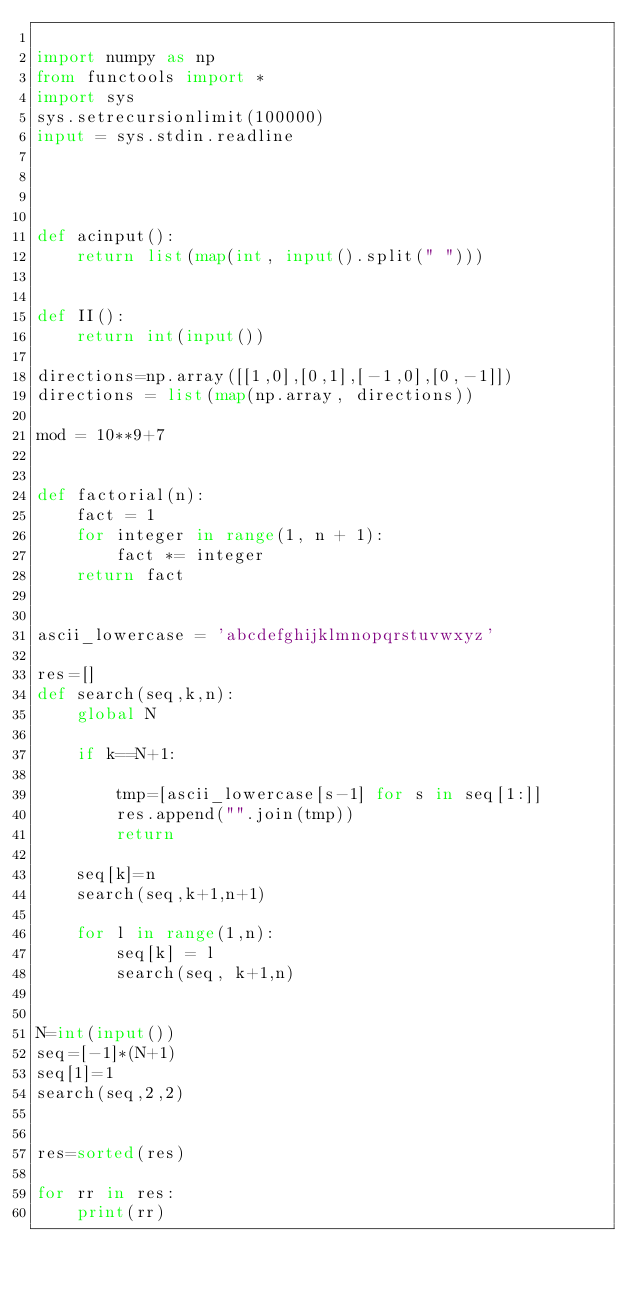Convert code to text. <code><loc_0><loc_0><loc_500><loc_500><_Python_>
import numpy as np
from functools import *
import sys
sys.setrecursionlimit(100000)
input = sys.stdin.readline




def acinput():
    return list(map(int, input().split(" ")))


def II():
    return int(input())

directions=np.array([[1,0],[0,1],[-1,0],[0,-1]])
directions = list(map(np.array, directions))

mod = 10**9+7


def factorial(n):
    fact = 1
    for integer in range(1, n + 1):
        fact *= integer
    return fact


ascii_lowercase = 'abcdefghijklmnopqrstuvwxyz'

res=[]
def search(seq,k,n):
    global N
    
    if k==N+1:

        tmp=[ascii_lowercase[s-1] for s in seq[1:]]
        res.append("".join(tmp))
        return 
    
    seq[k]=n
    search(seq,k+1,n+1)
    
    for l in range(1,n):
        seq[k] = l
        search(seq, k+1,n)
    

N=int(input())
seq=[-1]*(N+1)
seq[1]=1
search(seq,2,2)


res=sorted(res)

for rr in res:
    print(rr)</code> 